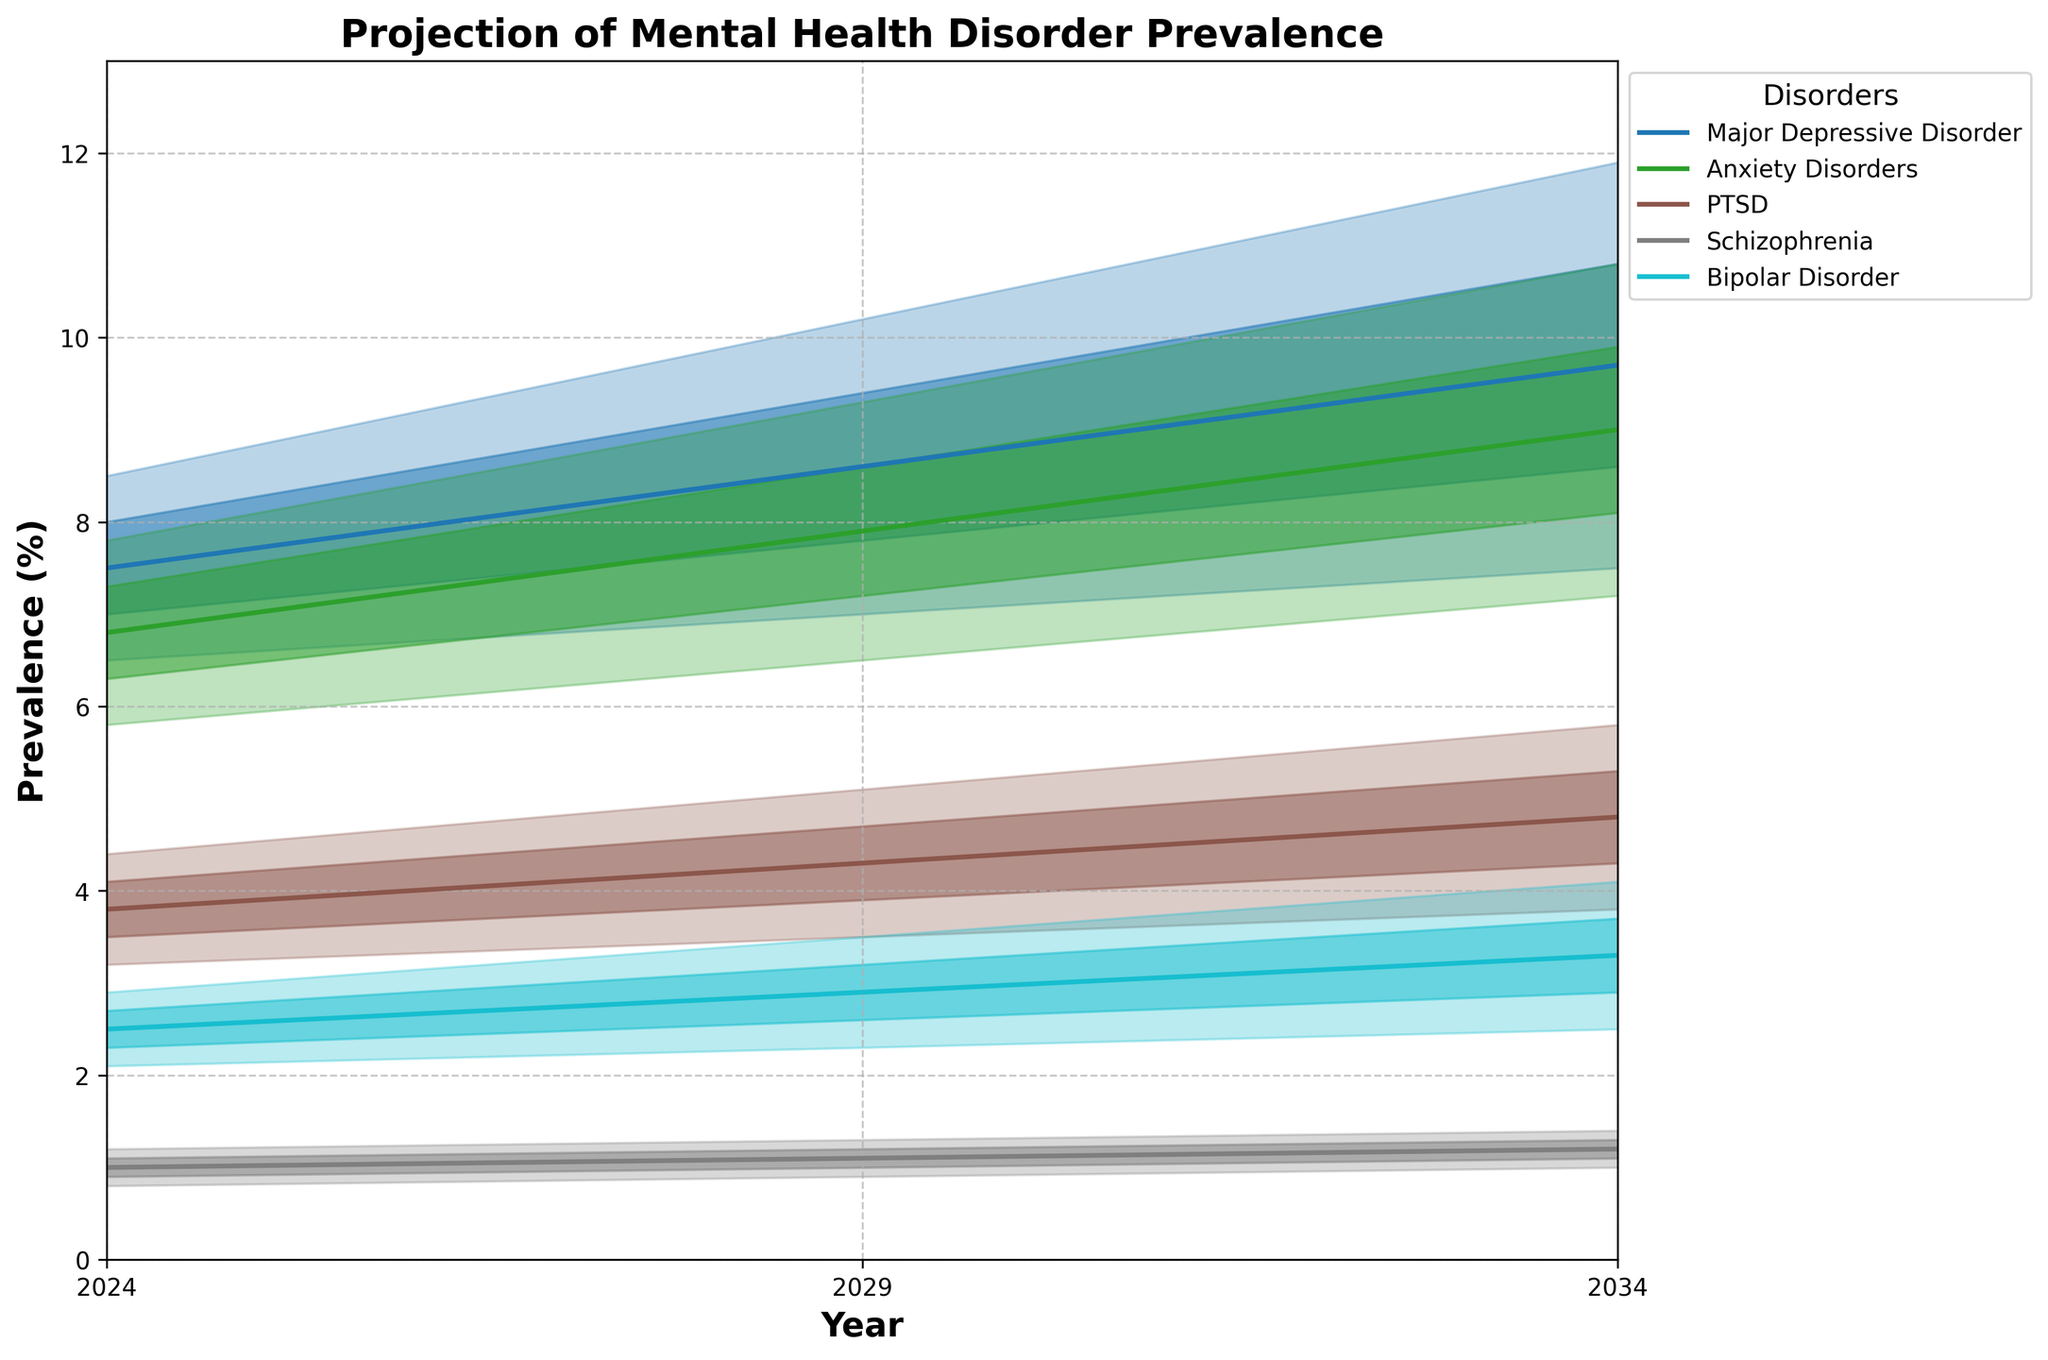Which disorder is projected to have the highest prevalence in 2034? The disorder with the highest "Mid" value in 2034 will have the highest prevalence. From the chart, Major Depressive Disorder has a "Mid" value of 10.8%.
Answer: Major Depressive Disorder What is the general trend for the prevalence of Anxiety Disorders from 2024 to 2034? By observing the "Mid" line for Anxiety Disorders, we see an upward trend from 6.8% in 2024 to 9.9% in 2034.
Answer: Increasing For PTSD, what is the difference in the 'Mid' prevalence value between 2024 and 2029? The "Mid" value for PTSD in 2024 is 3.8%, and in 2029, it is 4.3%. The difference is 4.3 - 3.8.
Answer: 0.5% Which disorder shows the most significant expected increase in prevalence based on the "Mid" values from 2024 to 2034? We need to find the disorder with the largest increase in "Mid" values between 2024 and 2034. For Major Depressive Disorder, the increase is 10.8 - 7.5 = 3.3%. Anxiety Disorders have an increase of 9.9 - 6.8 = 3.1%. PTSD has an increase of 5.3 - 3.8 = 1.5%. Schizophrenia has an increase of 1.3 - 1.0 = 0.3%. Bipolar Disorder has an increase of 3.7 - 2.5 = 1.2%. Major Depressive Disorder has the most significant increase.
Answer: Major Depressive Disorder By 2034, which disorder is projected to have the smallest range of uncertainty in prevalence? Range of uncertainty is the difference between the "High" and "Low" values for each disorder in 2034. For Schizophrenia, the range is 1.4 - 1.0 = 0.4. The other disorders have larger ranges.
Answer: Schizophrenia Which disorder has the least variation in 'Mid' values from 2024 to 2034? We calculate the absolute change in ‘Mid’ values for each disorder over the years. Schizophrenia changes from 1.0% in 2024 to 1.2% in 2034, a change of 0.2%. This is the smallest among all disorders.
Answer: Schizophrenia In 2029, which disorder has the largest range between the 'Low' and 'High' prevalence values? The range between 'Low' and 'High' values in 2029 for each disorder is as follows: Major Depressive Disorder (10.2 - 7.0 = 3.2%), Anxiety Disorders (9.3 - 6.5 = 2.8%), PTSD (5.1 - 3.5 = 1.6%), Schizophrenia (1.3 - 0.9 = 0.4%), Bipolar Disorder (3.5 - 2.3 = 1.2%). Major Depressive Disorder has the largest range.
Answer: Major Depressive Disorder 